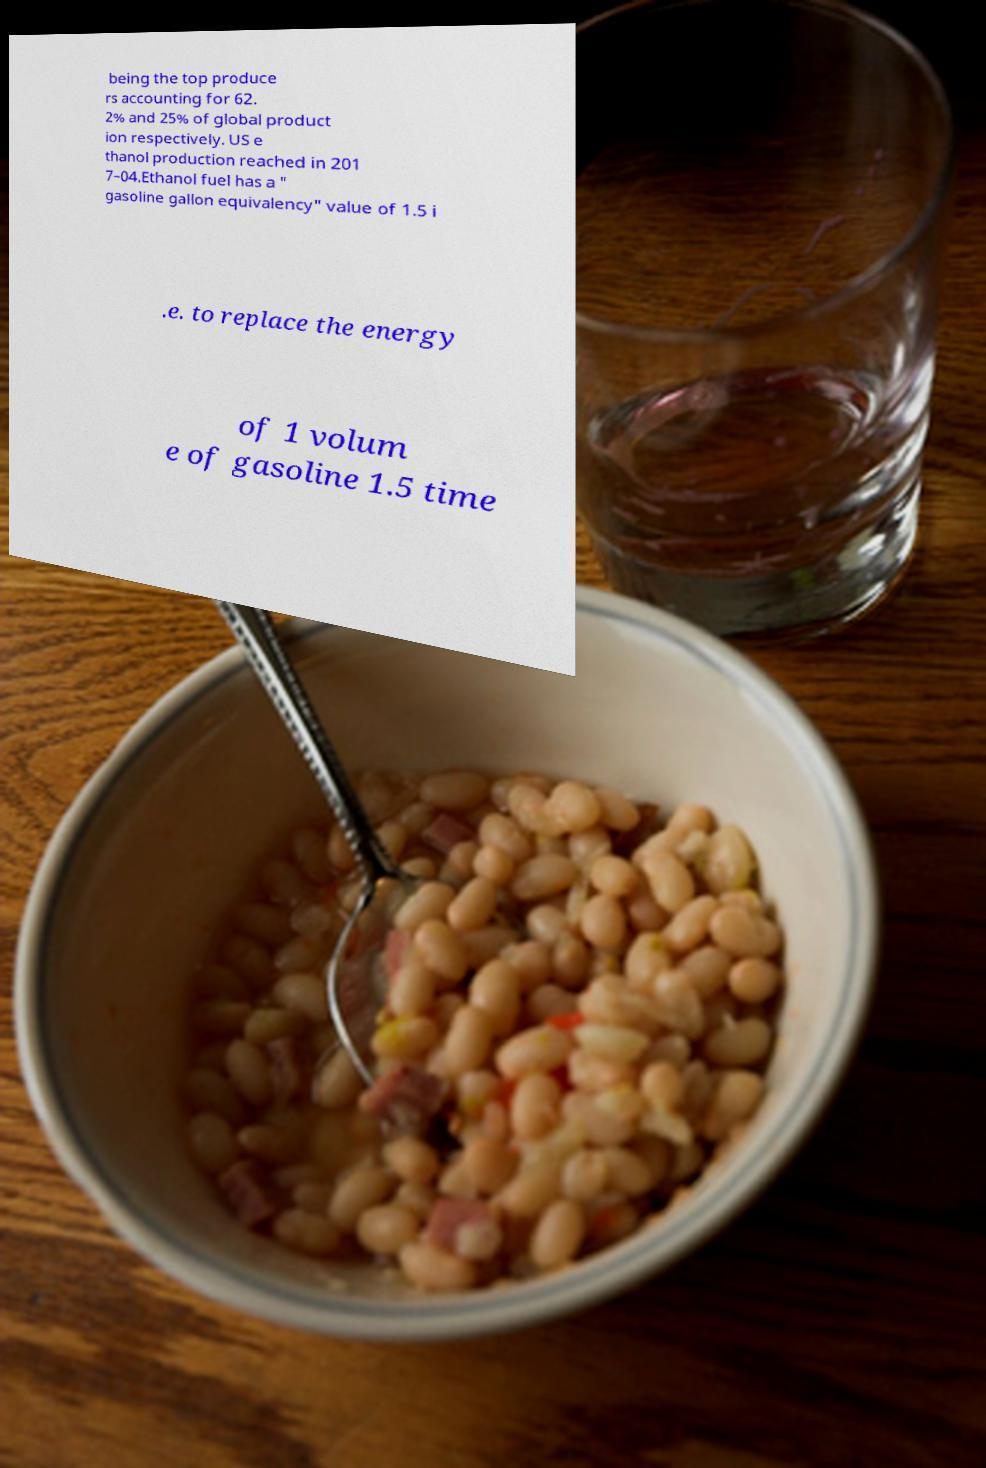Could you extract and type out the text from this image? being the top produce rs accounting for 62. 2% and 25% of global product ion respectively. US e thanol production reached in 201 7–04.Ethanol fuel has a " gasoline gallon equivalency" value of 1.5 i .e. to replace the energy of 1 volum e of gasoline 1.5 time 